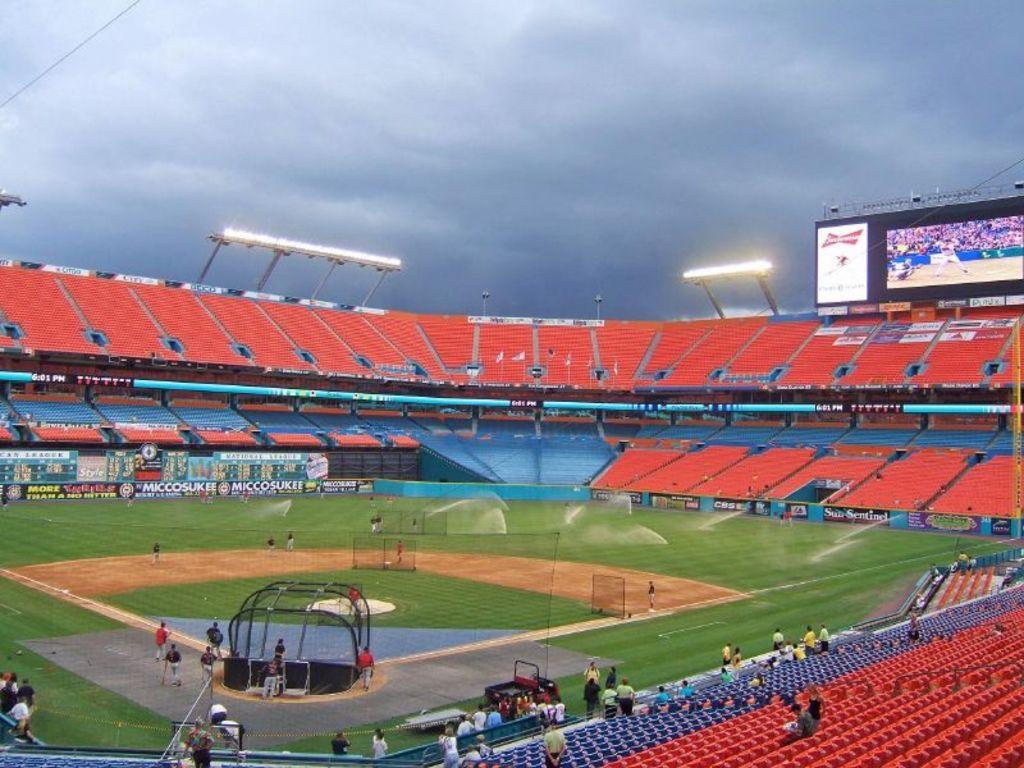Can you describe this image briefly? In this image I can see the stadium. I can see few red and blue color chairs, nets, sprinklers, few people, boards, vehicle, lights and the screen. The sky is in blue and white color. 